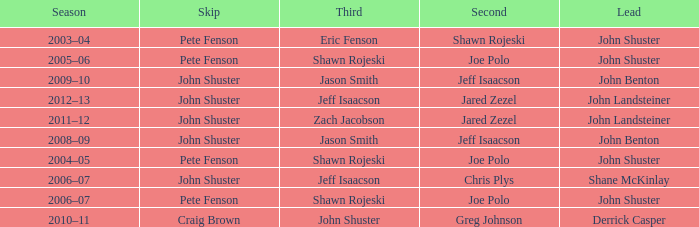Who was the lead with Pete Fenson as skip and Joe Polo as second in season 2005–06? John Shuster. 